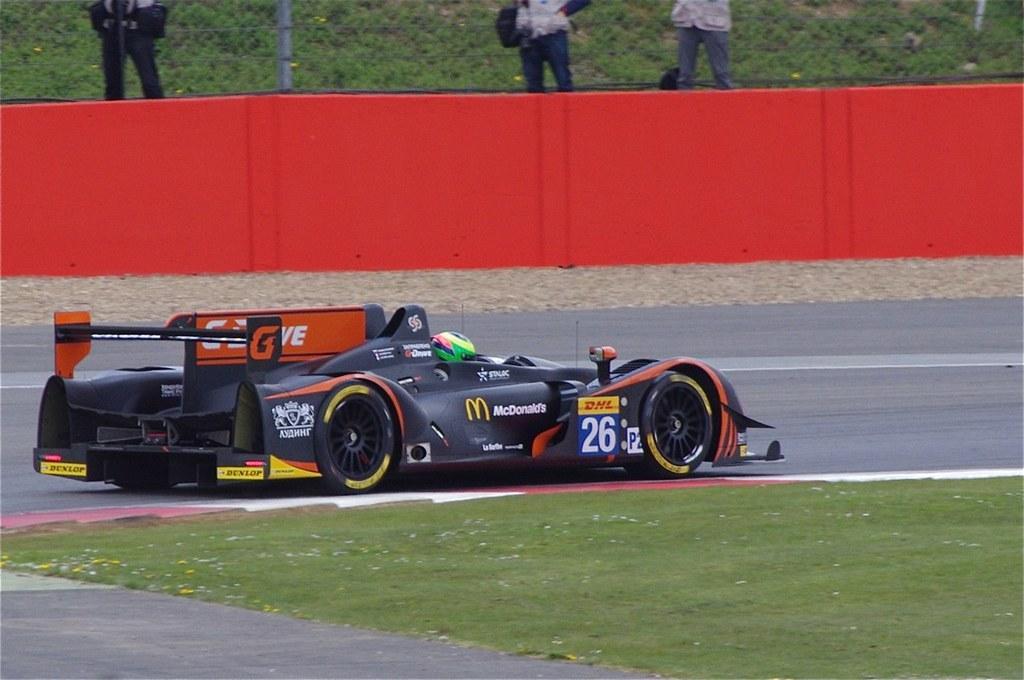Describe this image in one or two sentences. In the image we can see a racing car on the road. There are even people standing, wearing clothes. Her we can see a road, grass, red borders and fence. 